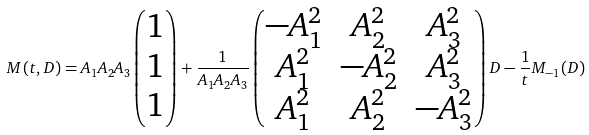<formula> <loc_0><loc_0><loc_500><loc_500>M ( t , D ) = A _ { 1 } A _ { 2 } A _ { 3 } \begin{pmatrix} 1 \\ 1 \\ 1 \end{pmatrix} + \frac { 1 } { A _ { 1 } A _ { 2 } A _ { 3 } } \begin{pmatrix} - A _ { 1 } ^ { 2 } & A _ { 2 } ^ { 2 } & A _ { 3 } ^ { 2 } \\ A _ { 1 } ^ { 2 } & - A _ { 2 } ^ { 2 } & A _ { 3 } ^ { 2 } \\ A _ { 1 } ^ { 2 } & A _ { 2 } ^ { 2 } & - A _ { 3 } ^ { 2 } \end{pmatrix} D - \frac { 1 } { t } M _ { - 1 } ( D )</formula> 